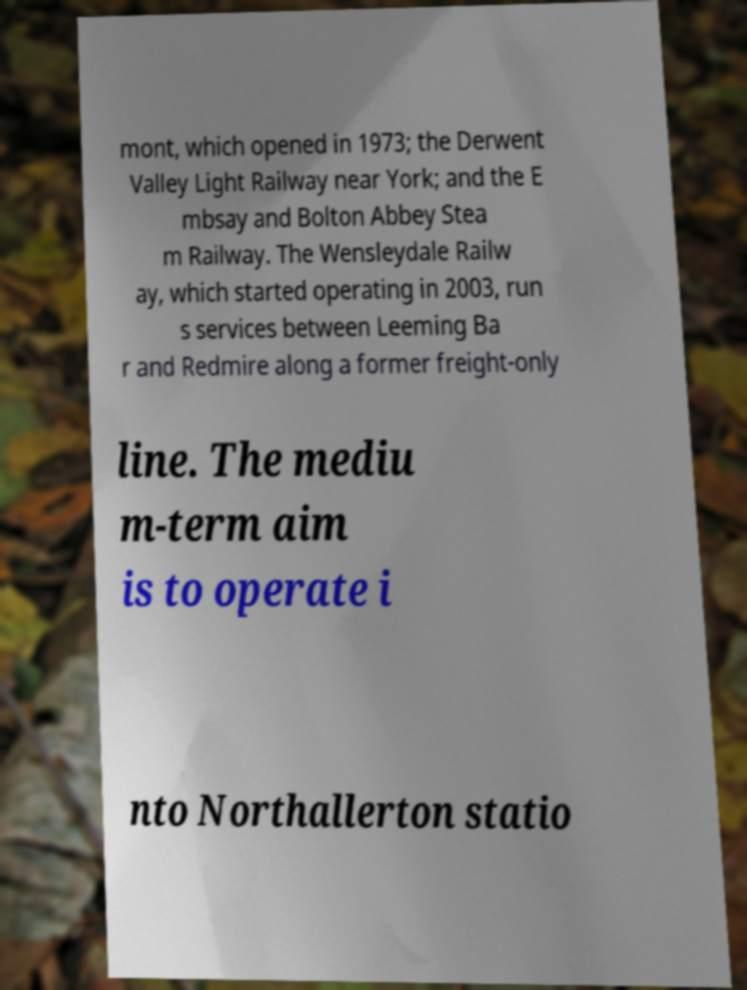I need the written content from this picture converted into text. Can you do that? mont, which opened in 1973; the Derwent Valley Light Railway near York; and the E mbsay and Bolton Abbey Stea m Railway. The Wensleydale Railw ay, which started operating in 2003, run s services between Leeming Ba r and Redmire along a former freight-only line. The mediu m-term aim is to operate i nto Northallerton statio 